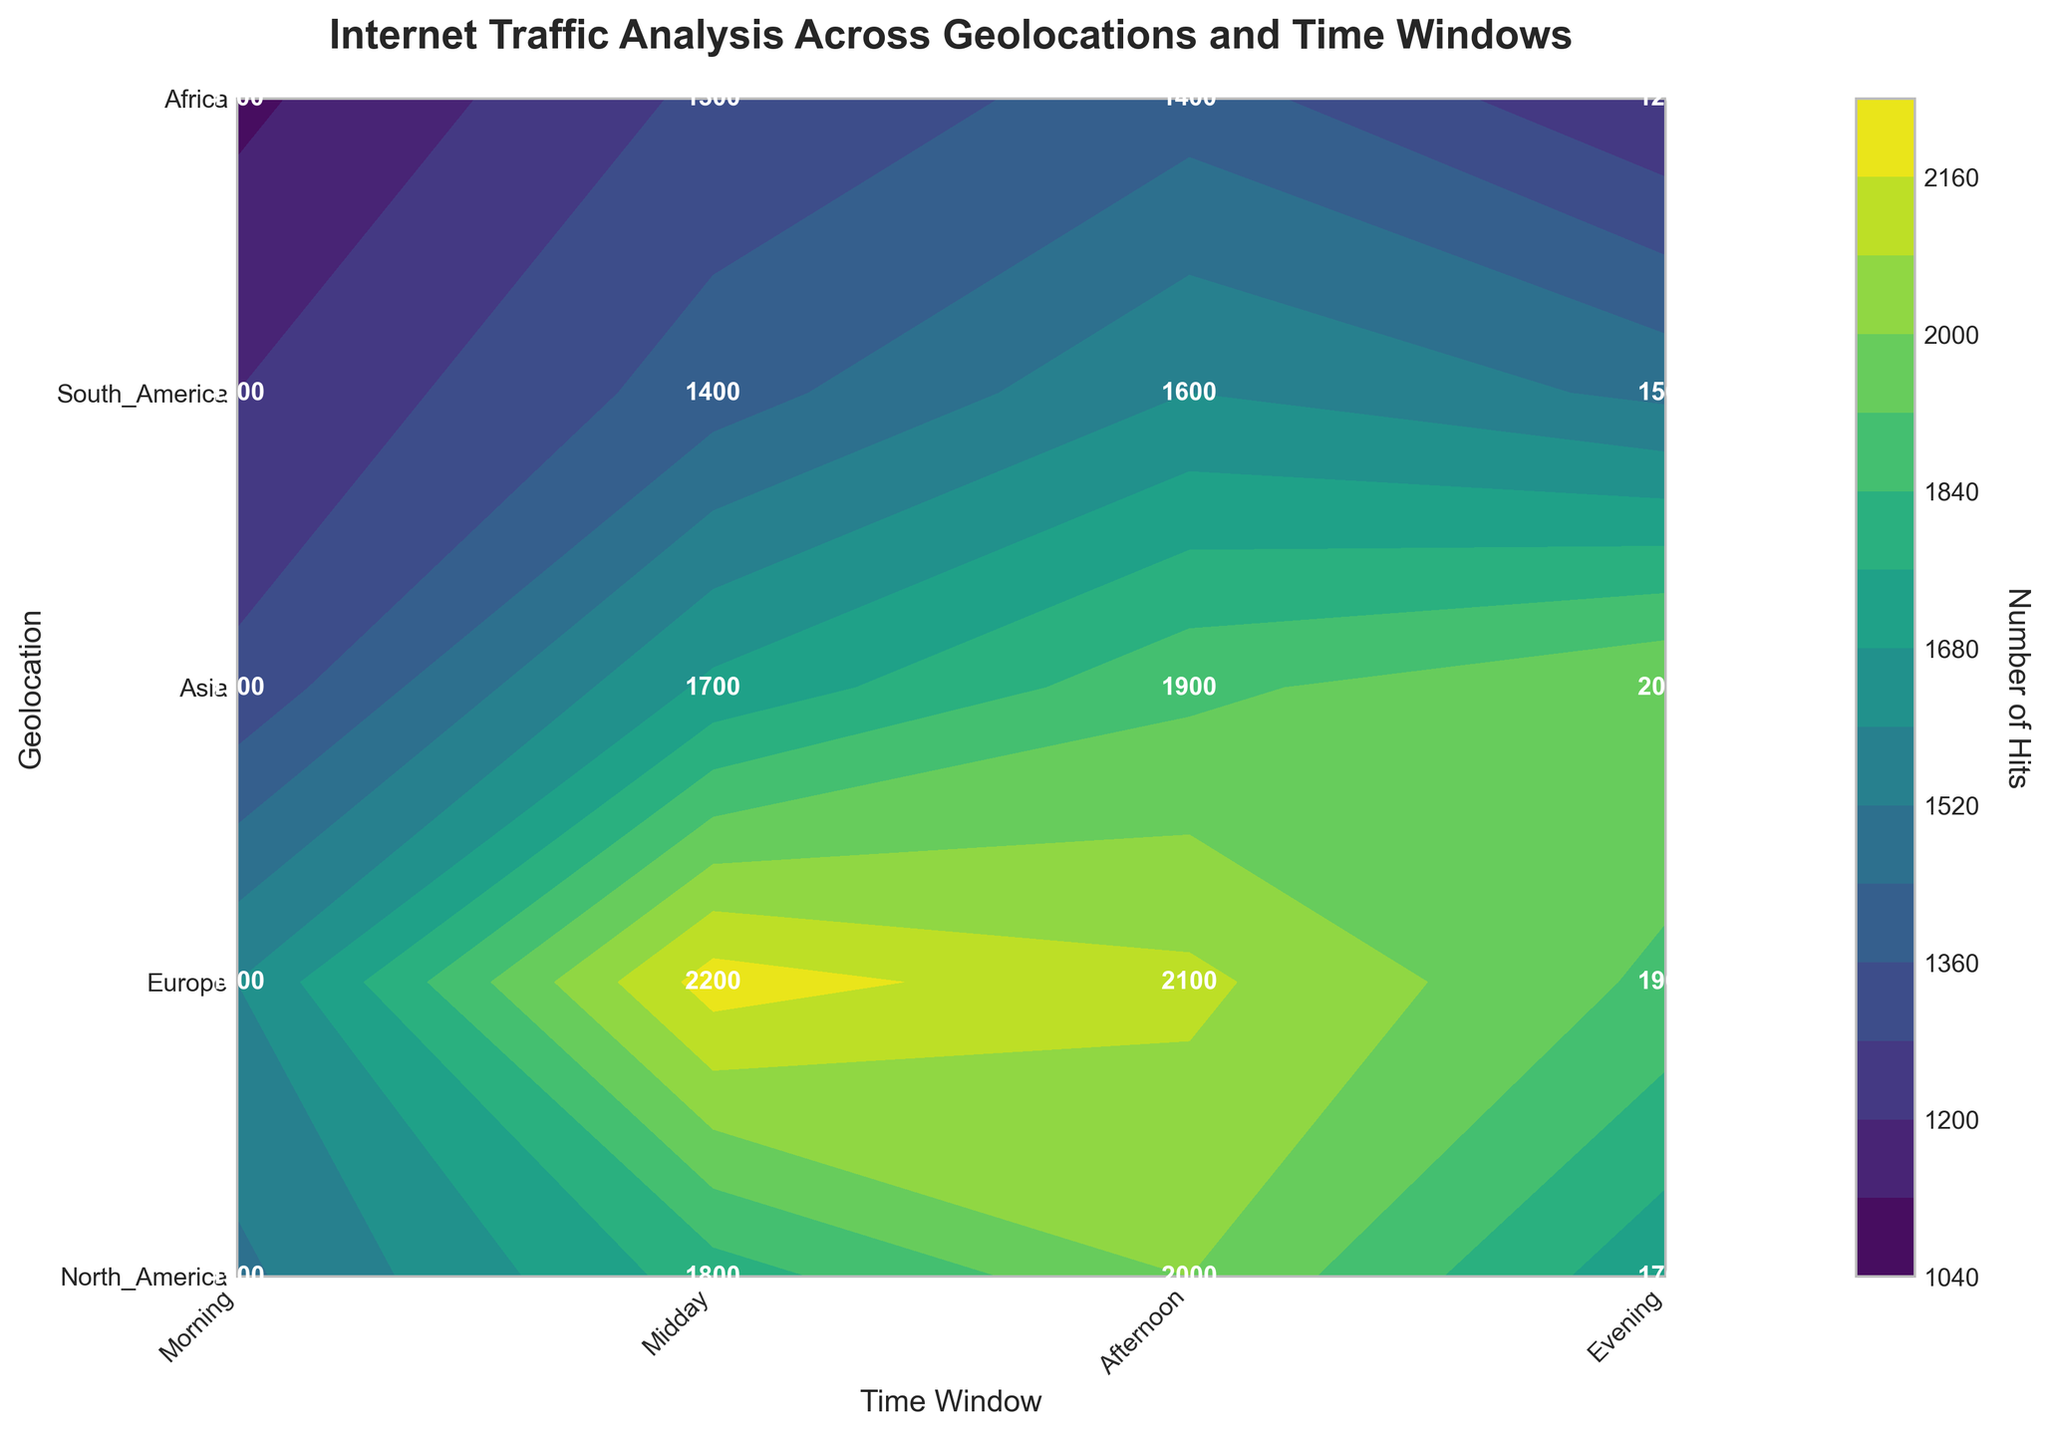What is the title of the figure? The title of a figure is usually displayed at the top and provides a brief description of the content or data represented in the plot. In this case, it is "Internet Traffic Analysis Across Geolocations and Time Windows".
Answer: Internet Traffic Analysis Across Geolocations and Time Windows Which geolocation has the highest number of hits during the Midday time window? To find this, locate the column for "Midday" and compare the values across all geolocations in that column. The highest value is 2200 hits, which corresponds to Europe.
Answer: Europe How many total hits does North America have across all time windows? To calculate this, sum the number of hits for North America across the four time windows: 1500 (Morning) + 1800 (Midday) + 2000 (Afternoon) + 1700 (Evening) = 7000.
Answer: 7000 Which time window has the least traffic in Africa? Look at the row for Africa and compare the values across the four time windows. The smallest value is 1100, which corresponds to the Morning time window.
Answer: Morning What is the average number of hits for Asia during the Afternoon and Evening time windows? Calculate the average by summing the hits during Afternoon (1900) and Evening (2000) and then dividing by the number of time windows (2). Thus, (1900 + 2000) / 2 = 1950.
Answer: 1950 Which geolocation has the most uniform traffic across all time windows? To determine this, compare the range (difference between the maximum and minimum values) of hits for each geolocation. Africa has hits ranging from 1100 to 1400, a range of 300, which is the smallest among all geolocations, indicating the most uniform distribution.
Answer: Africa During which time window does South America see the most hits, and what is that number? In the row for South America, compare the values for the four time windows. The highest value is 1600 hits, which occurs in the Afternoon time window.
Answer: Afternoon, 1600 What is the total number of hits during the Evening time window across all geolocations? Sum the number of hits in the Evening column across all geolocations: 1700 (North America) + 1900 (Europe) + 2000 (Asia) + 1500 (South America) + 1200 (Africa) = 8300.
Answer: 8300 Is there any time window where every geolocation has more than 1500 hits? Compare the number of hits for each geolocation across the four time windows to see if there is any window where all values exceed 1500. Upon checking, no single time window has hits greater than 1500 for every geolocation.
Answer: No Between Morning and Evening, which has higher total hits across all geolocations? Sum the hits for both time windows across all geolocations and compare: Morning total = 1500 + 1600 + 1300 + 1200 + 1100 = 6700; Evening total = 1700 + 1900 + 2000 + 1500 + 1200 = 8300. Evening has higher total hits.
Answer: Evening 